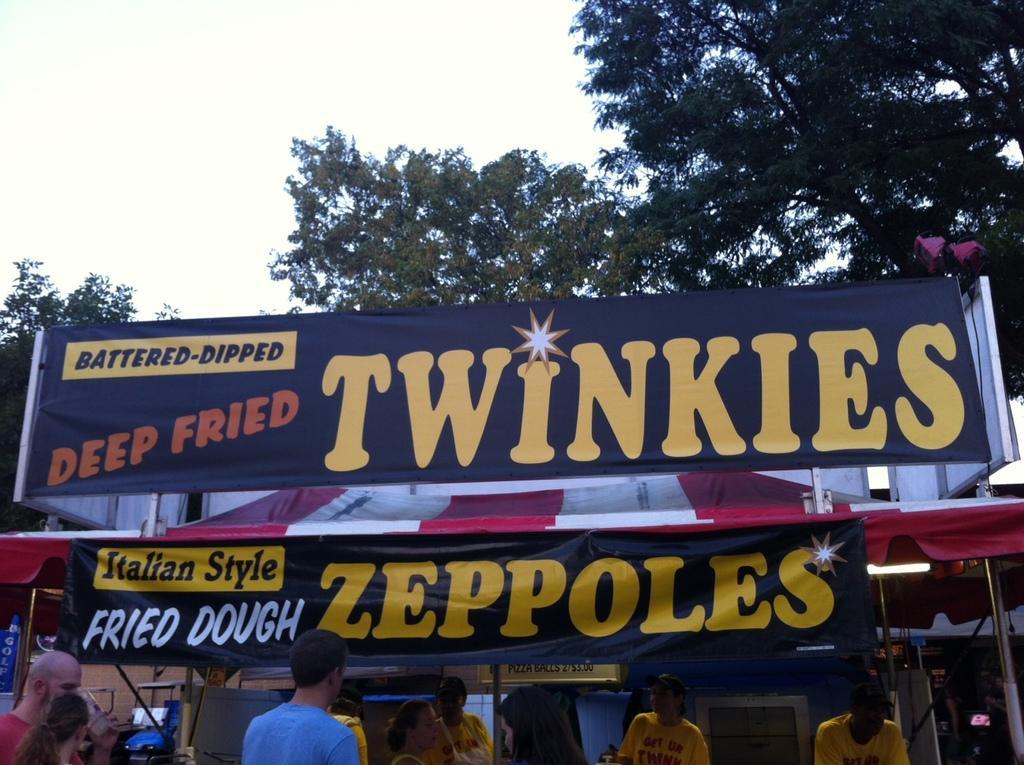Could you give a brief overview of what you see in this image? In the foreground I can see a crowd, food truck and a board. In the background I can see trees and the sky. This image is taken during a day. 